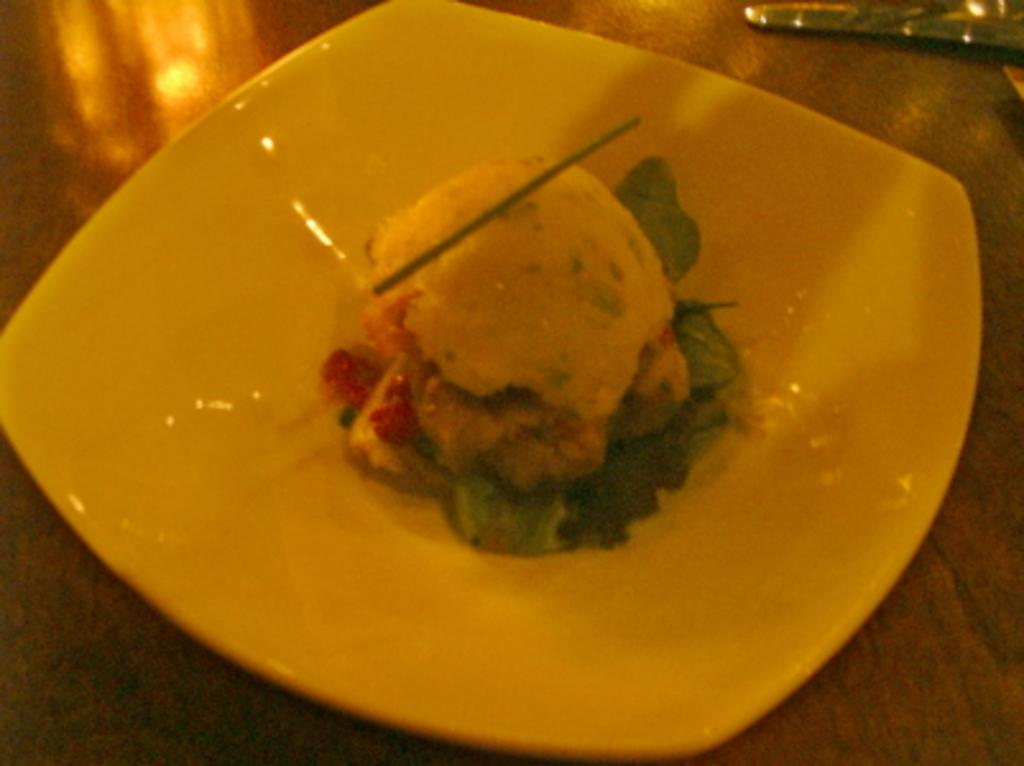What object is present in the image that can hold food? There is a plate in the image. What color is the plate? The plate is white in color. What is on the plate? There are food items on the plate. What type of suit is the person wearing while riding the horses in the image? There are no people, suits, or horses present in the image; it only features a plate with food items. 